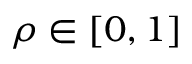Convert formula to latex. <formula><loc_0><loc_0><loc_500><loc_500>\rho \in \left [ 0 , 1 \right ]</formula> 